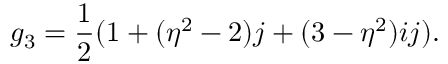Convert formula to latex. <formula><loc_0><loc_0><loc_500><loc_500>g _ { 3 } = { \frac { 1 } { 2 } } ( 1 + ( \eta ^ { 2 } - 2 ) j + ( 3 - \eta ^ { 2 } ) i j ) .</formula> 